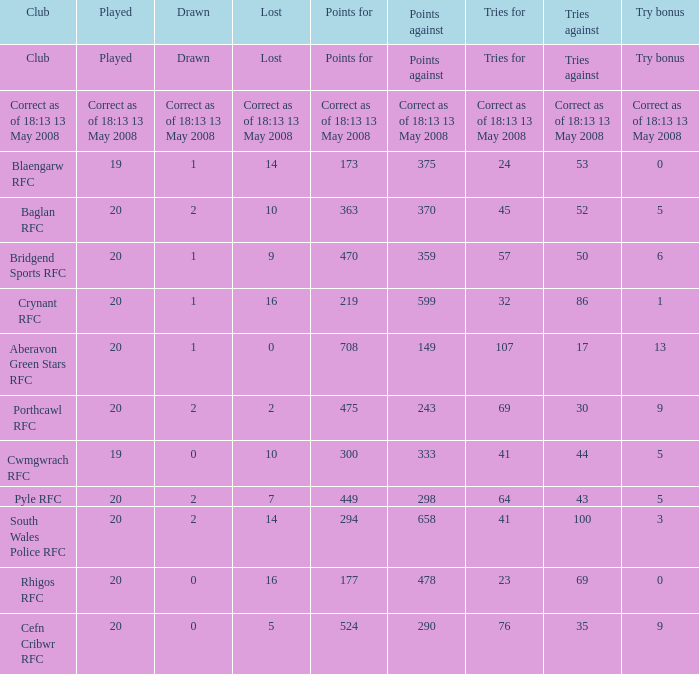What is the tries against when the points are 475? 30.0. Parse the table in full. {'header': ['Club', 'Played', 'Drawn', 'Lost', 'Points for', 'Points against', 'Tries for', 'Tries against', 'Try bonus'], 'rows': [['Club', 'Played', 'Drawn', 'Lost', 'Points for', 'Points against', 'Tries for', 'Tries against', 'Try bonus'], ['Correct as of 18:13 13 May 2008', 'Correct as of 18:13 13 May 2008', 'Correct as of 18:13 13 May 2008', 'Correct as of 18:13 13 May 2008', 'Correct as of 18:13 13 May 2008', 'Correct as of 18:13 13 May 2008', 'Correct as of 18:13 13 May 2008', 'Correct as of 18:13 13 May 2008', 'Correct as of 18:13 13 May 2008'], ['Blaengarw RFC', '19', '1', '14', '173', '375', '24', '53', '0'], ['Baglan RFC', '20', '2', '10', '363', '370', '45', '52', '5'], ['Bridgend Sports RFC', '20', '1', '9', '470', '359', '57', '50', '6'], ['Crynant RFC', '20', '1', '16', '219', '599', '32', '86', '1'], ['Aberavon Green Stars RFC', '20', '1', '0', '708', '149', '107', '17', '13'], ['Porthcawl RFC', '20', '2', '2', '475', '243', '69', '30', '9'], ['Cwmgwrach RFC', '19', '0', '10', '300', '333', '41', '44', '5'], ['Pyle RFC', '20', '2', '7', '449', '298', '64', '43', '5'], ['South Wales Police RFC', '20', '2', '14', '294', '658', '41', '100', '3'], ['Rhigos RFC', '20', '0', '16', '177', '478', '23', '69', '0'], ['Cefn Cribwr RFC', '20', '0', '5', '524', '290', '76', '35', '9']]} 